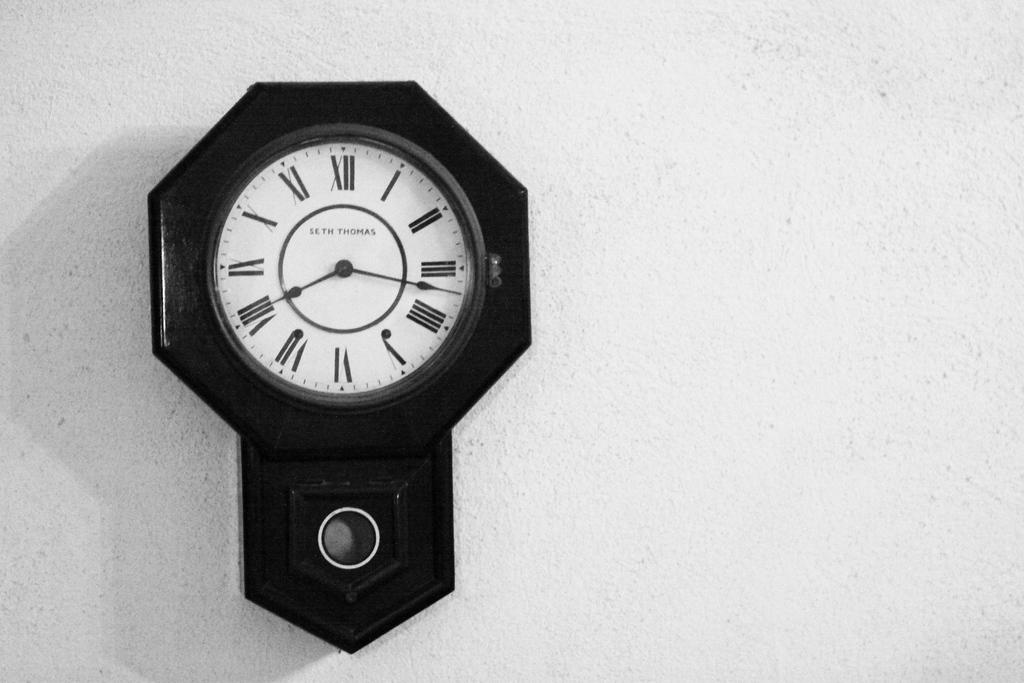What object in the image can be used to tell time? There is a clock in the image that can be used to tell time. Where is the clock located in the image? The clock is on a wall in the image. What colors are used to make the clock? The clock is in white and black color. Can you see any steam coming from the clock in the image? There is no steam present in the image, as it features a clock on a wall. What type of disease is the clock treating in the image? There is no mention of a disease in the image, as it features a clock on a wall. 